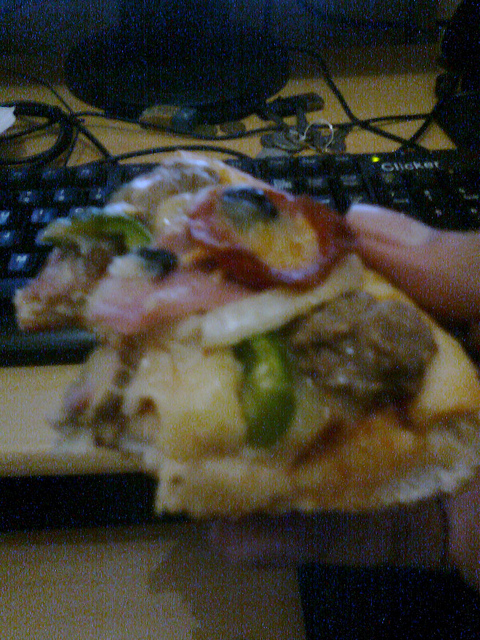Does this setting suggest this person is multitasking? Yes, the presence of a computer keyboard next to where pizza is being eaten suggests that the person might be working while eating, indicating multitasking. 